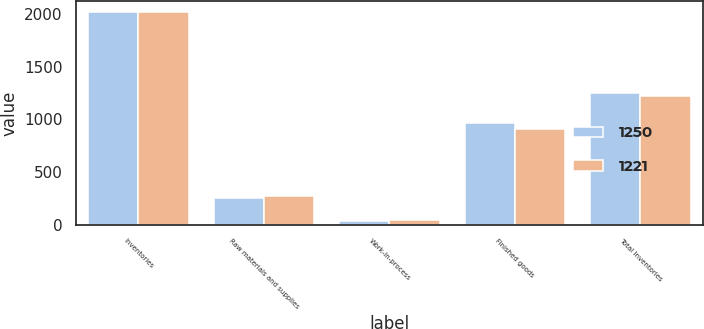Convert chart to OTSL. <chart><loc_0><loc_0><loc_500><loc_500><stacked_bar_chart><ecel><fcel>Inventories<fcel>Raw materials and supplies<fcel>Work-in-process<fcel>Finished goods<fcel>Total Inventories<nl><fcel>1250<fcel>2018<fcel>253<fcel>37<fcel>960<fcel>1250<nl><fcel>1221<fcel>2017<fcel>267<fcel>42<fcel>912<fcel>1221<nl></chart> 